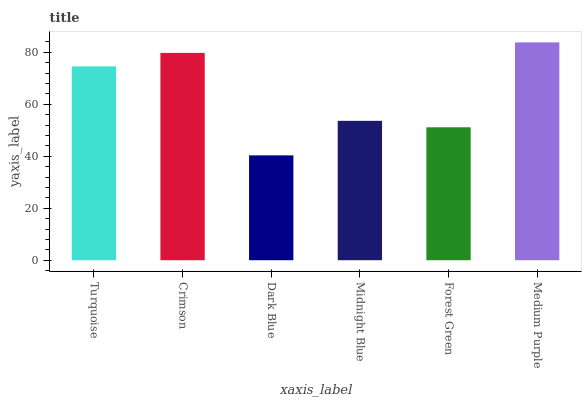Is Dark Blue the minimum?
Answer yes or no. Yes. Is Medium Purple the maximum?
Answer yes or no. Yes. Is Crimson the minimum?
Answer yes or no. No. Is Crimson the maximum?
Answer yes or no. No. Is Crimson greater than Turquoise?
Answer yes or no. Yes. Is Turquoise less than Crimson?
Answer yes or no. Yes. Is Turquoise greater than Crimson?
Answer yes or no. No. Is Crimson less than Turquoise?
Answer yes or no. No. Is Turquoise the high median?
Answer yes or no. Yes. Is Midnight Blue the low median?
Answer yes or no. Yes. Is Forest Green the high median?
Answer yes or no. No. Is Medium Purple the low median?
Answer yes or no. No. 